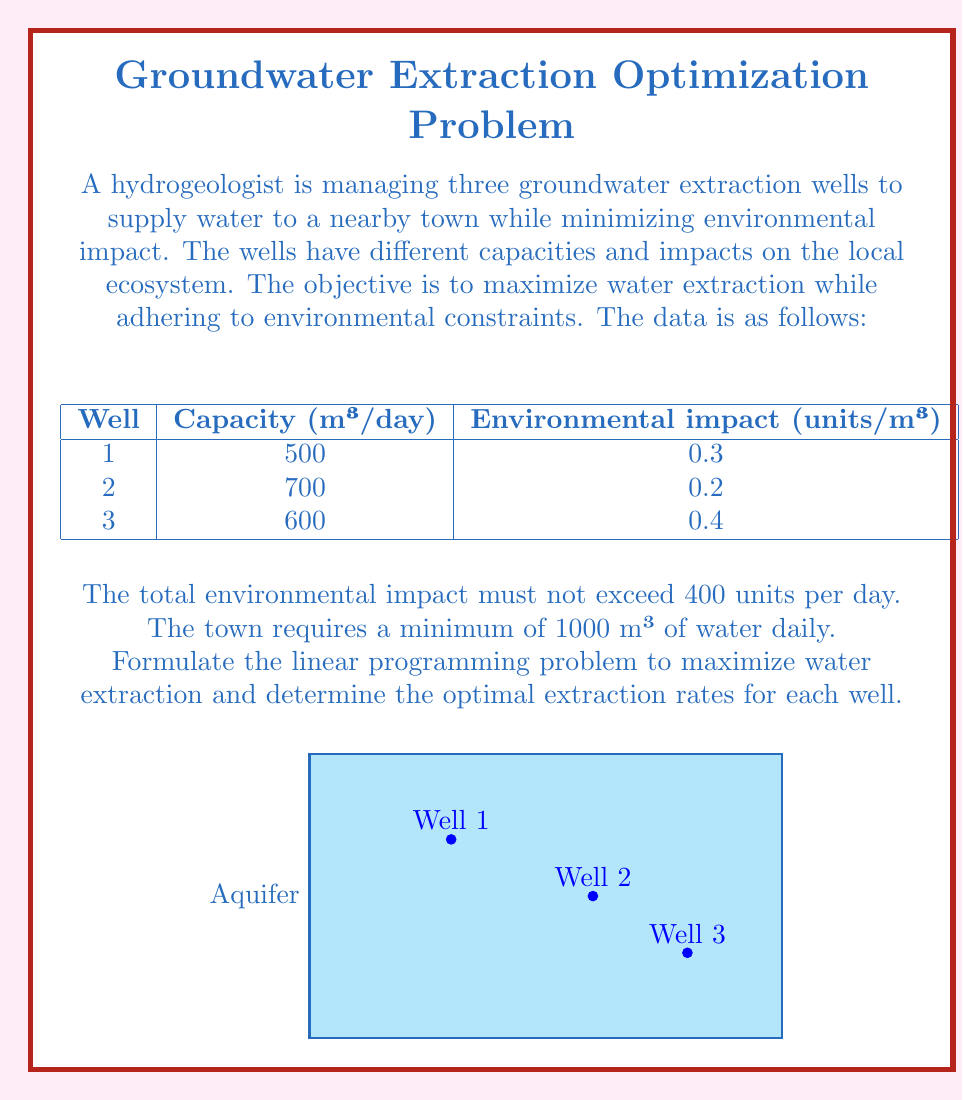Teach me how to tackle this problem. Let's approach this step-by-step:

1) Define variables:
   Let $x_1$, $x_2$, and $x_3$ be the daily extraction rates (in m³) for Wells 1, 2, and 3 respectively.

2) Objective function:
   We want to maximize total water extraction:
   $$\text{Maximize } Z = x_1 + x_2 + x_3$$

3) Constraints:
   a) Capacity constraints:
      $x_1 \leq 500$
      $x_2 \leq 700$
      $x_3 \leq 600$

   b) Environmental impact constraint:
      $0.3x_1 + 0.2x_2 + 0.4x_3 \leq 400$

   c) Minimum water requirement:
      $x_1 + x_2 + x_3 \geq 1000$

   d) Non-negativity constraints:
      $x_1, x_2, x_3 \geq 0$

4) The complete linear programming model:

   $$\begin{align*}
   \text{Maximize } & Z = x_1 + x_2 + x_3 \\
   \text{Subject to: } & x_1 \leq 500 \\
   & x_2 \leq 700 \\
   & x_3 \leq 600 \\
   & 0.3x_1 + 0.2x_2 + 0.4x_3 \leq 400 \\
   & x_1 + x_2 + x_3 \geq 1000 \\
   & x_1, x_2, x_3 \geq 0
   \end{align*}$$

5) To solve this, we would typically use a solver or the simplex method. However, we can deduce the optimal solution by considering the environmental impact per unit of water:

   Well 2 has the least impact (0.2 units/m³), so we should maximize its use.
   Well 1 has the second least impact (0.3 units/m³).
   Well 3 has the highest impact (0.4 units/m³), so we should use it last.

6) Optimal solution:
   Extract 700 m³ from Well 2 (its full capacity)
   Extract 500 m³ from Well 1 (its full capacity)
   Extract 0 m³ from Well 3

   This gives a total of 1200 m³, which satisfies the minimum requirement.
   The total environmental impact is: $0.2(700) + 0.3(500) + 0.4(0) = 290$ units, which is within the limit.

Therefore, the optimal extraction rates are:
$x_1 = 500$, $x_2 = 700$, $x_3 = 0$
Answer: Well 1: 500 m³/day, Well 2: 700 m³/day, Well 3: 0 m³/day 